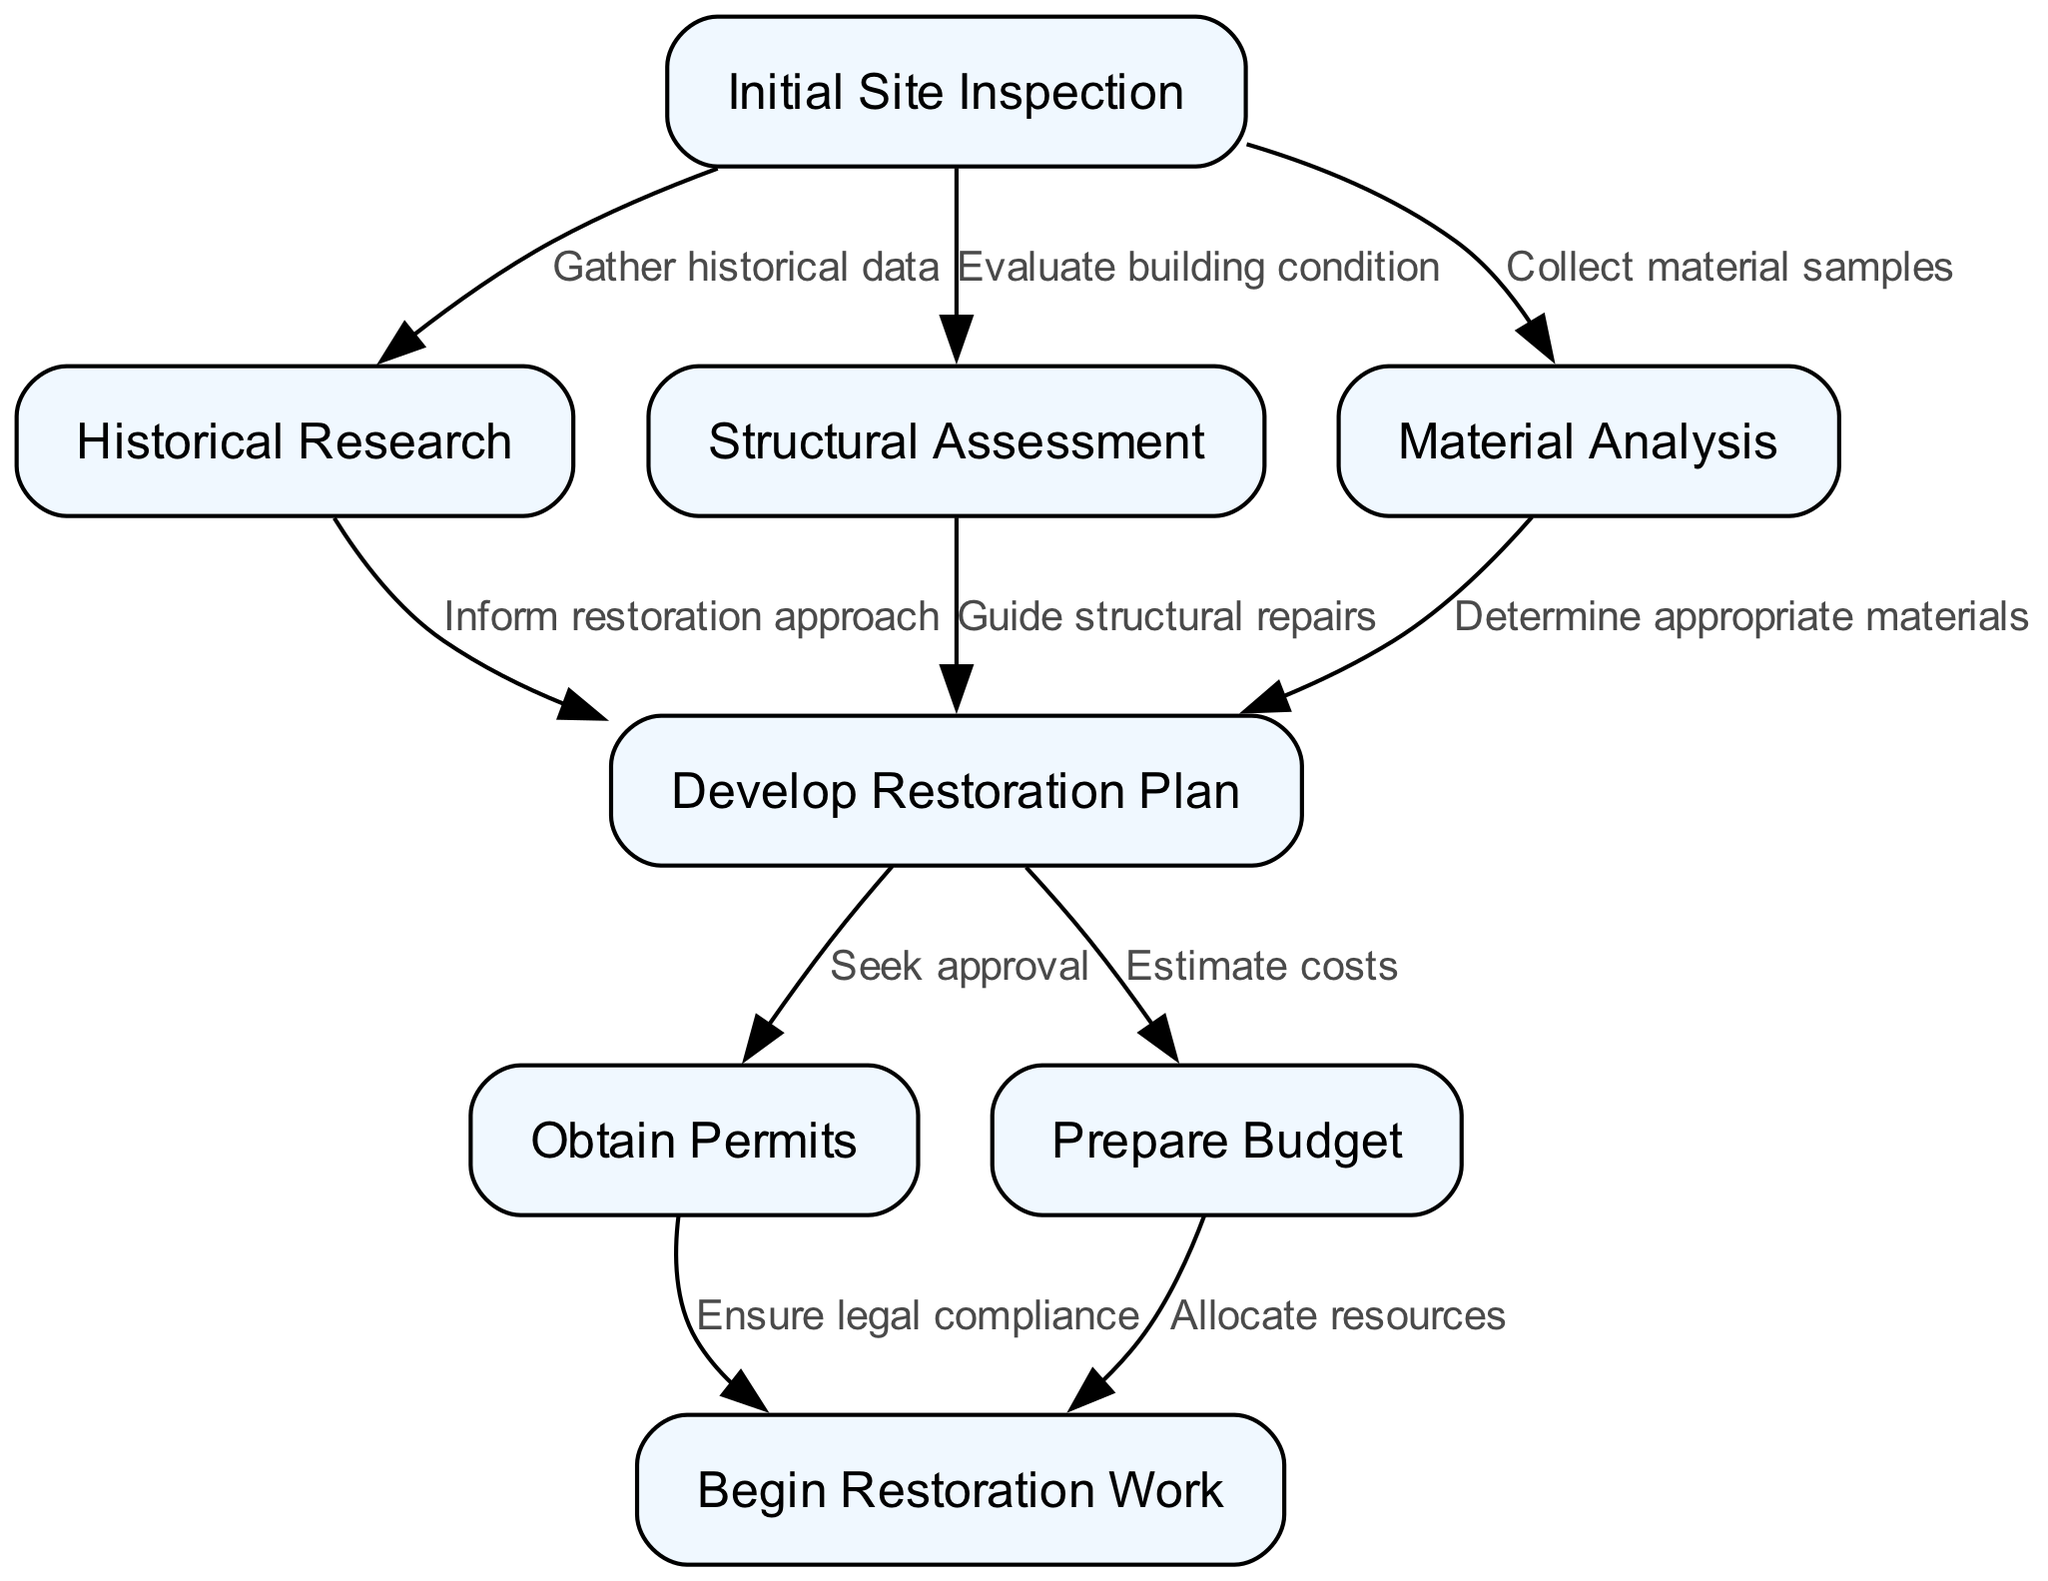What is the first step in the restoration process? The diagram indicates that the initial step in the process is "Initial Site Inspection." This node is the starting point and does not have any incoming edges.
Answer: Initial Site Inspection How many nodes are in the diagram? The diagram contains eight nodes, each representing a distinct step in the restoration process. This can be confirmed by counting each node listed in the data provided.
Answer: Eight What occurs after "Develop Restoration Plan"? The diagram shows that "Develop Restoration Plan" leads directly to two actions: "Obtain Permits" and "Prepare Budget." Therefore, both actions occur after this step.
Answer: Obtain Permits and Prepare Budget What is the relationship between "Historical Research" and "Develop Restoration Plan"? According to the diagram, "Historical Research" informs the restoration approach, which subsequently plays a role in "Develop Restoration Plan." The edge directly indicates this relationship.
Answer: Inform restoration approach How many edges are present in the flowchart? The diagram features nine edges that represent the connections and steps in the restoration process. Counting each edge confirms this quantity.
Answer: Nine What is required before beginning restoration work? To begin restoration work, the diagram specifies that "Obtain Permits" must occur first to ensure legal compliance prior to commencing any physical work on the building.
Answer: Obtain Permits Which step informs structural repairs? The diagram shows that "Structural Assessment" guides the structural repairs, illustrated by the directed edge from this node to the "Develop Restoration Plan." This connection is crucial for planning repairs.
Answer: Guide structural repairs What is the last step in the flowchart? The final node in the flowchart is "Begin Restoration Work," which has no outgoing edges, indicating it is the concluding action in the process.
Answer: Begin Restoration Work 